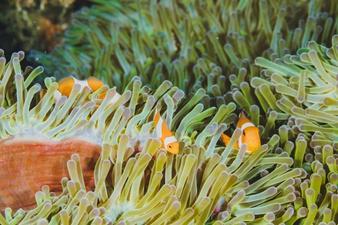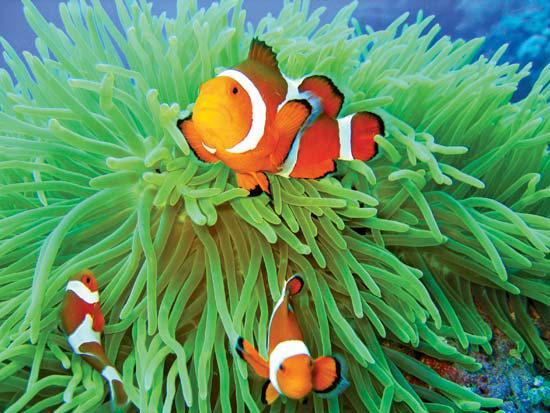The first image is the image on the left, the second image is the image on the right. Considering the images on both sides, is "The left image features an anemone with a wide violet-colored stalk, and the right image shows multiple leftward-turned clownfish swimming among anemone tendrils." valid? Answer yes or no. No. The first image is the image on the left, the second image is the image on the right. Considering the images on both sides, is "There are three clownfish next to a sea anemone in the right image" valid? Answer yes or no. Yes. 